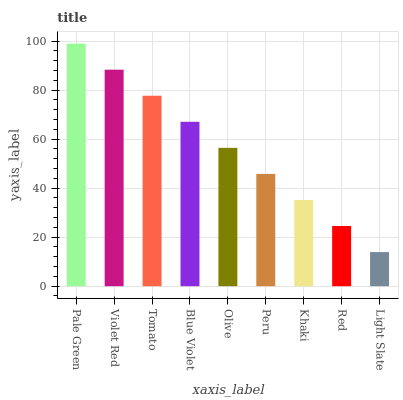Is Light Slate the minimum?
Answer yes or no. Yes. Is Pale Green the maximum?
Answer yes or no. Yes. Is Violet Red the minimum?
Answer yes or no. No. Is Violet Red the maximum?
Answer yes or no. No. Is Pale Green greater than Violet Red?
Answer yes or no. Yes. Is Violet Red less than Pale Green?
Answer yes or no. Yes. Is Violet Red greater than Pale Green?
Answer yes or no. No. Is Pale Green less than Violet Red?
Answer yes or no. No. Is Olive the high median?
Answer yes or no. Yes. Is Olive the low median?
Answer yes or no. Yes. Is Pale Green the high median?
Answer yes or no. No. Is Violet Red the low median?
Answer yes or no. No. 